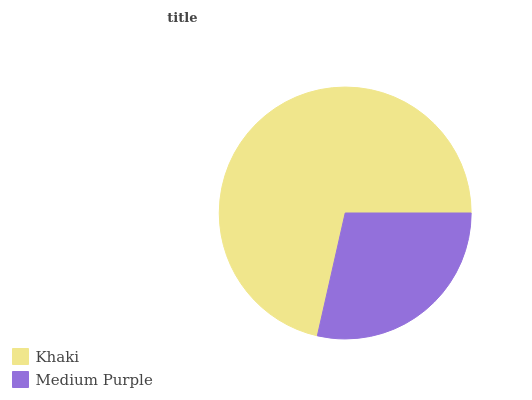Is Medium Purple the minimum?
Answer yes or no. Yes. Is Khaki the maximum?
Answer yes or no. Yes. Is Medium Purple the maximum?
Answer yes or no. No. Is Khaki greater than Medium Purple?
Answer yes or no. Yes. Is Medium Purple less than Khaki?
Answer yes or no. Yes. Is Medium Purple greater than Khaki?
Answer yes or no. No. Is Khaki less than Medium Purple?
Answer yes or no. No. Is Khaki the high median?
Answer yes or no. Yes. Is Medium Purple the low median?
Answer yes or no. Yes. Is Medium Purple the high median?
Answer yes or no. No. Is Khaki the low median?
Answer yes or no. No. 